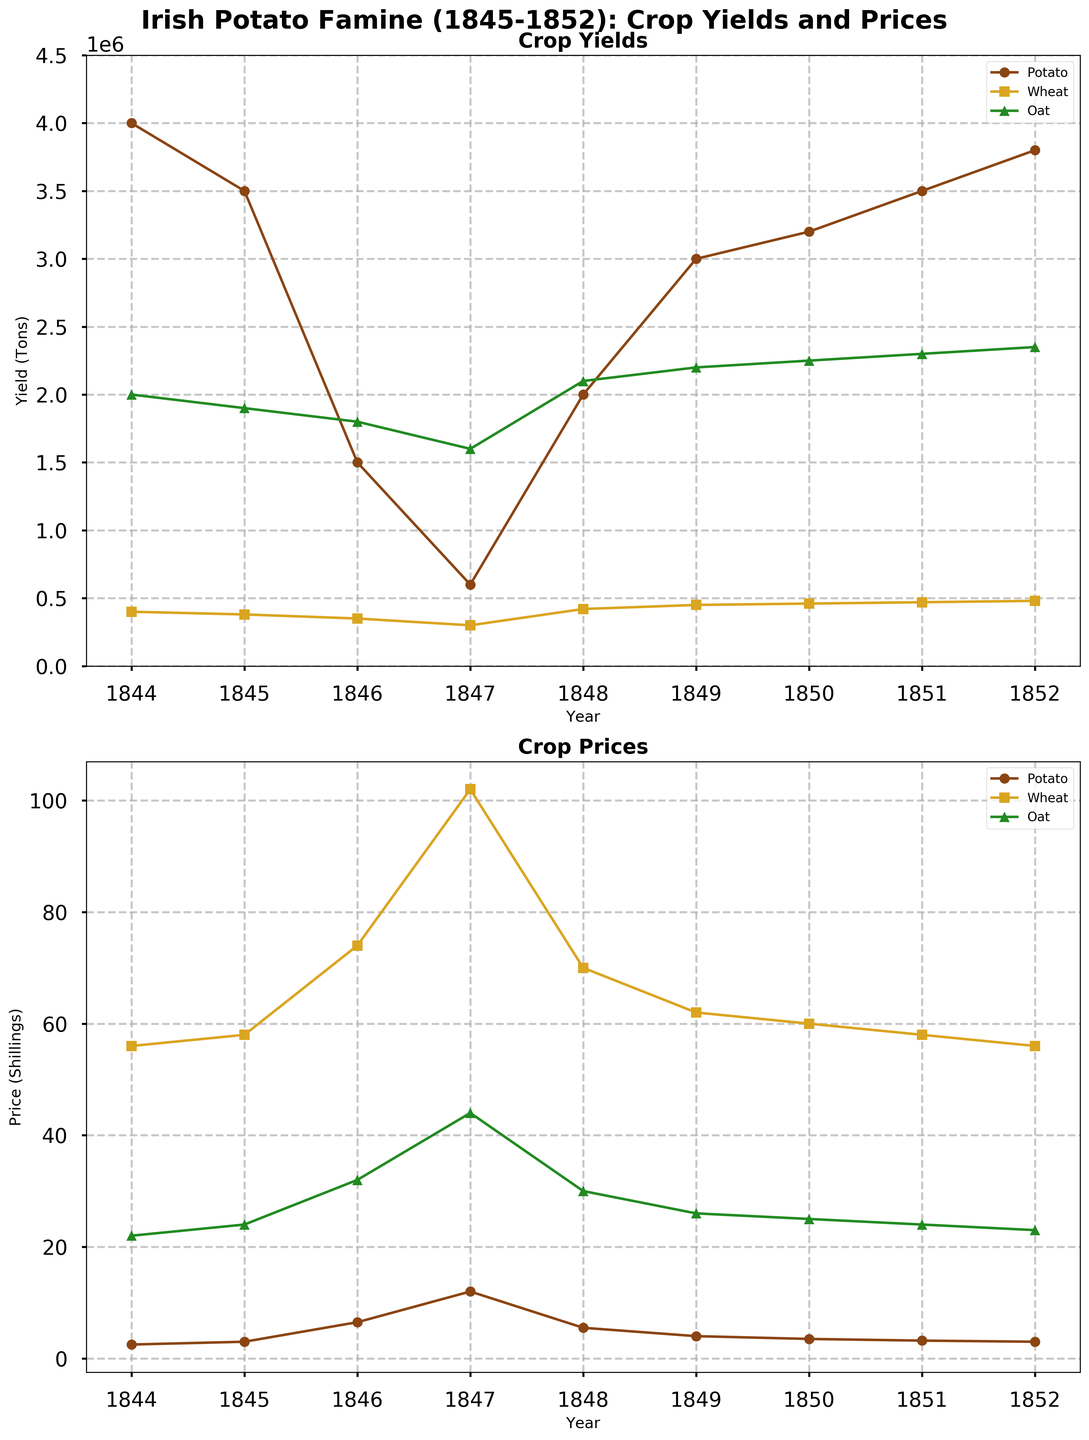What year did potato prices peak during the Irish Potato Famine? Locate the highest point on the line representing potato prices in the Crop Prices plot. The peak occurs in the year 1847, where the potato price reaches its maximum value.
Answer: 1847 Which crop's yield was the least affected (most stable) during the Irish Potato Famine based on the plot? Observe the pattern of the lines representing each crop's yield in the Crop Yields plot. The oat yield line shows the least fluctuation compared to potato and wheat.
Answer: Oat Which year had the lowest combined yield of potatoes and wheat? Add the yields of potatoes and wheat for each year and find the year with the lowest total. In 1847, the combined yield of potatoes and wheat (600,000 + 300,000 = 900,000 tons) is the lowest.
Answer: 1847 How did wheat prices change from 1846 to 1847? Compare the points on the line representing wheat prices between the years 1846 and 1847 in the Crop Prices plot. The price increases from 74 shillings in 1846 to 102 shillings in 1847.
Answer: Increased In which year was the gap between wheat yield and oat yield the smallest? Calculate the difference between wheat and oat yields for every year, and identify the year with the smallest gap. In 1847, the yields were 300,000 tons for wheat and 1,600,000 tons for oat, making the difference 1,300,000, which is the smallest gap.
Answer: 1847 Compare the yields of potatoes and oats in 1846. Which one was higher? Look at the points for the year 1846 in the Crop Yields plot and compare the values for potatoes (1,500,000 tons) and oats (1,800,000 tons). The oat yield is higher.
Answer: Oats By how much did the potato yield decrease from 1845 to 1846? Subtract the potato yield of 1846 from that of 1845 (3,500,000 tons - 1,500,000 tons). The decrease is 2,000,000 tons.
Answer: 2,000,000 tons Which crop’s price saw the greatest increase from 1844 to 1847? Calculate the difference in prices from 1844 to 1847 for each crop: Potato (12.0 - 2.5 = 9.5), Wheat (102 - 56 = 46), Oat (44 - 22 = 22). Wheat prices had the greatest increase of 46 shillings.
Answer: Wheat During which year did all three crop prices rise simultaneously? Observe the lines for all three crops in the Crop Prices plot and identify if there was a year when all lines show an increase from the previous year. In 1846, the prices of potatoes, wheat, and oats all rose.
Answer: 1846 What trend is observable in potato yields after the peak price year (1847)? Look at the potato yield line post-1847 in the Crop Yields plot. There is a noticeable increasing trend in potato yields from 1847 onwards.
Answer: Increasing 